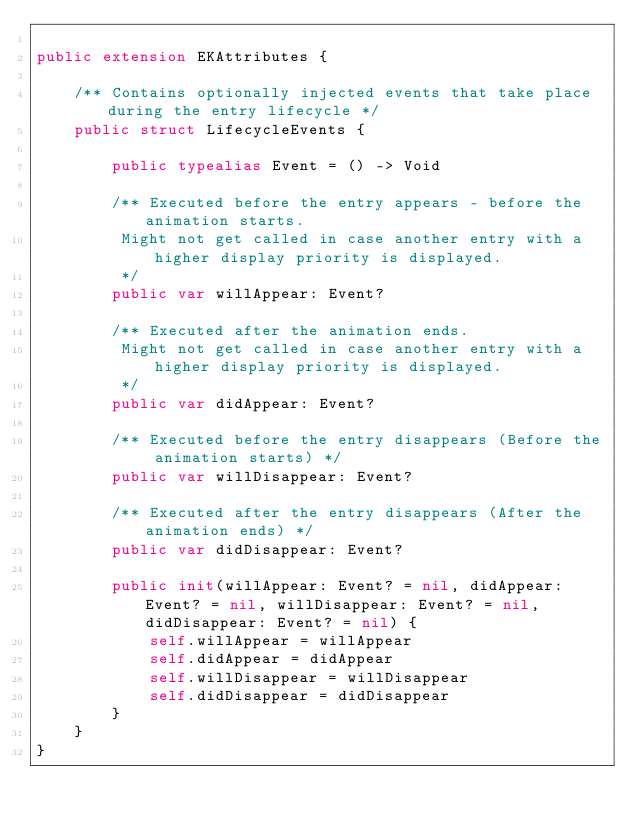Convert code to text. <code><loc_0><loc_0><loc_500><loc_500><_Swift_>
public extension EKAttributes {

    /** Contains optionally injected events that take place during the entry lifecycle */
    public struct LifecycleEvents {
        
        public typealias Event = () -> Void

        /** Executed before the entry appears - before the animation starts.
         Might not get called in case another entry with a higher display priority is displayed.
         */
        public var willAppear: Event?
        
        /** Executed after the animation ends.
         Might not get called in case another entry with a higher display priority is displayed.
         */
        public var didAppear: Event?

        /** Executed before the entry disappears (Before the animation starts) */
        public var willDisappear: Event?
        
        /** Executed after the entry disappears (After the animation ends) */
        public var didDisappear: Event?
        
        public init(willAppear: Event? = nil, didAppear: Event? = nil, willDisappear: Event? = nil, didDisappear: Event? = nil) {
            self.willAppear = willAppear
            self.didAppear = didAppear
            self.willDisappear = willDisappear
            self.didDisappear = didDisappear
        }
    }
}
</code> 